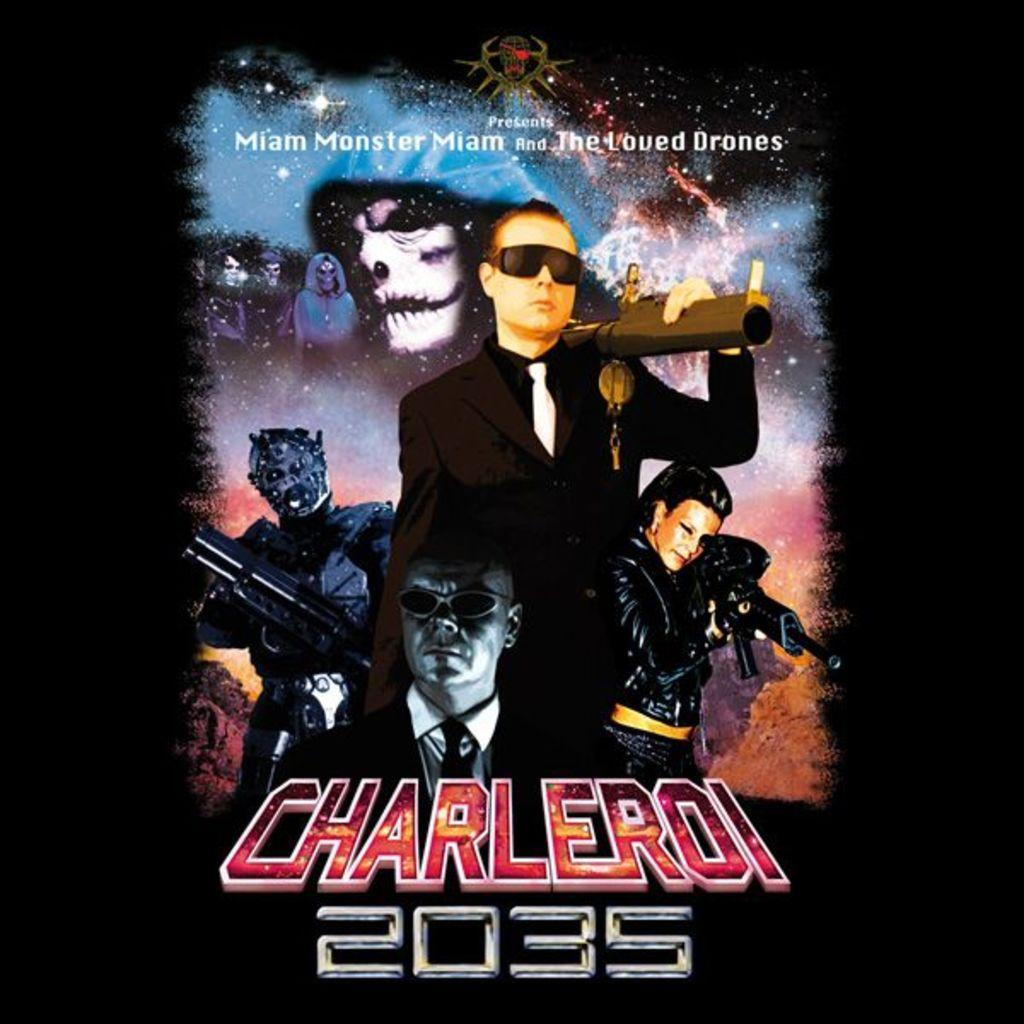<image>
Summarize the visual content of the image. poster featuring people and monsters dressed in black and it is labeled charleroi 2035 